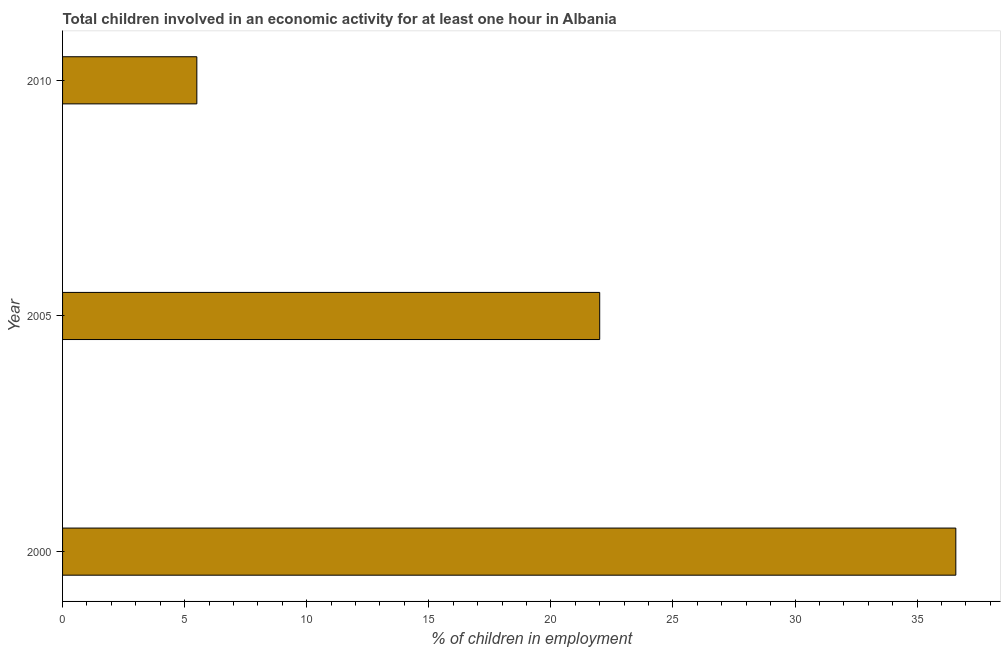Does the graph contain any zero values?
Make the answer very short. No. What is the title of the graph?
Offer a terse response. Total children involved in an economic activity for at least one hour in Albania. What is the label or title of the X-axis?
Your answer should be very brief. % of children in employment. What is the label or title of the Y-axis?
Make the answer very short. Year. Across all years, what is the maximum percentage of children in employment?
Keep it short and to the point. 36.59. Across all years, what is the minimum percentage of children in employment?
Your response must be concise. 5.5. In which year was the percentage of children in employment maximum?
Provide a short and direct response. 2000. What is the sum of the percentage of children in employment?
Provide a succinct answer. 64.09. What is the difference between the percentage of children in employment in 2000 and 2010?
Your answer should be very brief. 31.09. What is the average percentage of children in employment per year?
Provide a short and direct response. 21.36. What is the median percentage of children in employment?
Your response must be concise. 22. In how many years, is the percentage of children in employment greater than 37 %?
Offer a very short reply. 0. Do a majority of the years between 2000 and 2005 (inclusive) have percentage of children in employment greater than 9 %?
Make the answer very short. Yes. What is the ratio of the percentage of children in employment in 2000 to that in 2010?
Offer a very short reply. 6.65. What is the difference between the highest and the second highest percentage of children in employment?
Make the answer very short. 14.59. Is the sum of the percentage of children in employment in 2000 and 2005 greater than the maximum percentage of children in employment across all years?
Provide a short and direct response. Yes. What is the difference between the highest and the lowest percentage of children in employment?
Give a very brief answer. 31.09. How many bars are there?
Offer a terse response. 3. Are all the bars in the graph horizontal?
Your answer should be very brief. Yes. What is the % of children in employment of 2000?
Your answer should be compact. 36.59. What is the % of children in employment in 2010?
Make the answer very short. 5.5. What is the difference between the % of children in employment in 2000 and 2005?
Keep it short and to the point. 14.59. What is the difference between the % of children in employment in 2000 and 2010?
Make the answer very short. 31.09. What is the ratio of the % of children in employment in 2000 to that in 2005?
Your response must be concise. 1.66. What is the ratio of the % of children in employment in 2000 to that in 2010?
Provide a succinct answer. 6.65. What is the ratio of the % of children in employment in 2005 to that in 2010?
Ensure brevity in your answer.  4. 